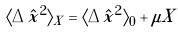<formula> <loc_0><loc_0><loc_500><loc_500>\langle \Delta \hat { x } ^ { 2 } \rangle _ { X } = \langle \Delta \hat { x } ^ { 2 } \rangle _ { 0 } + \mu X</formula> 